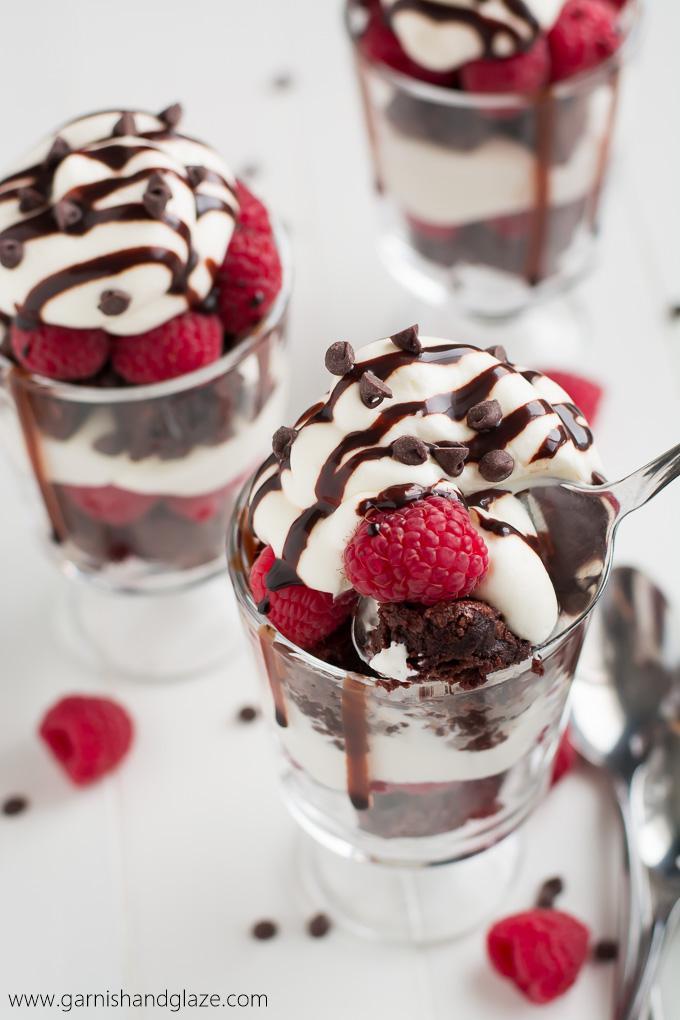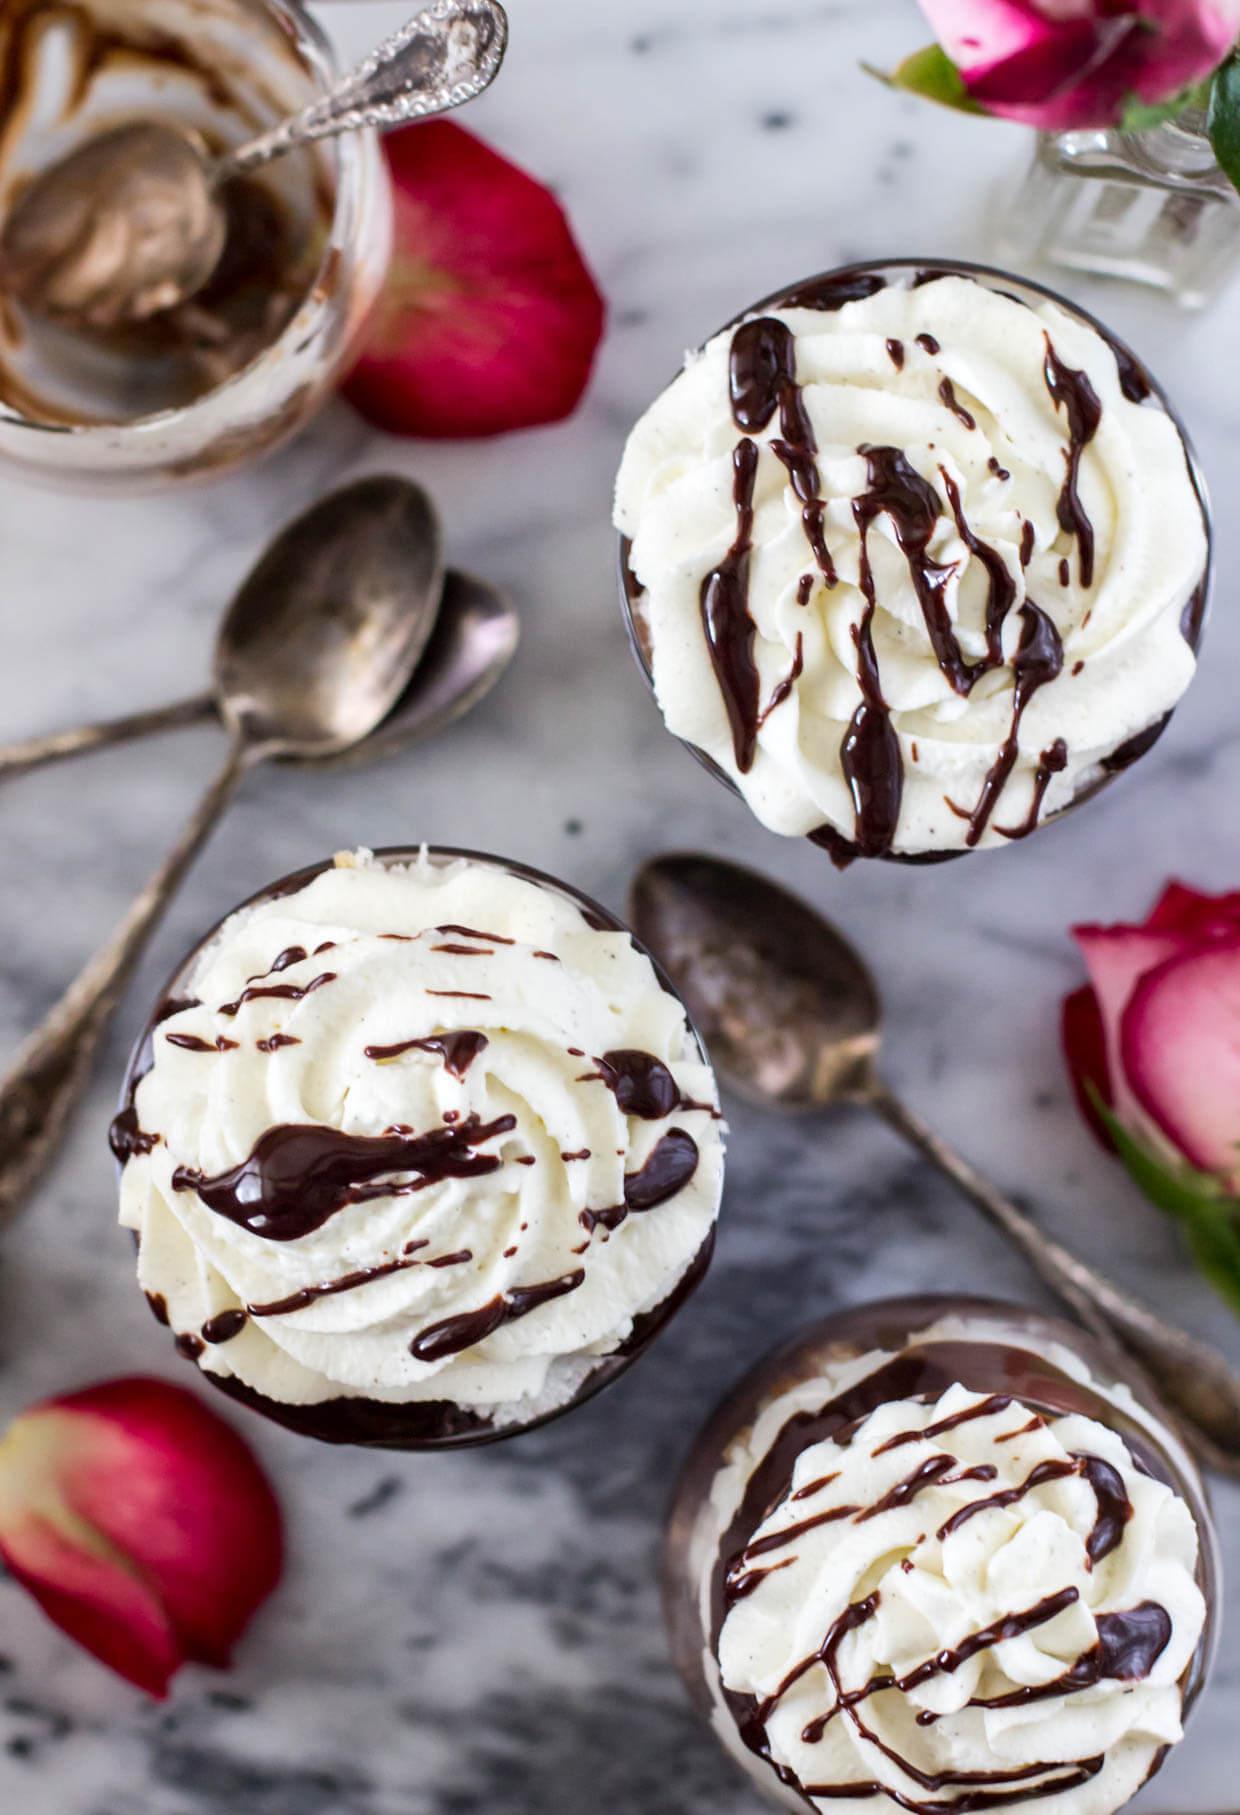The first image is the image on the left, the second image is the image on the right. Considering the images on both sides, is "there are roses on the table next to desserts with chocolate drizzled on top" valid? Answer yes or no. Yes. The first image is the image on the left, the second image is the image on the right. For the images displayed, is the sentence "6 desserts feature a bread/cake like filling." factually correct? Answer yes or no. No. 